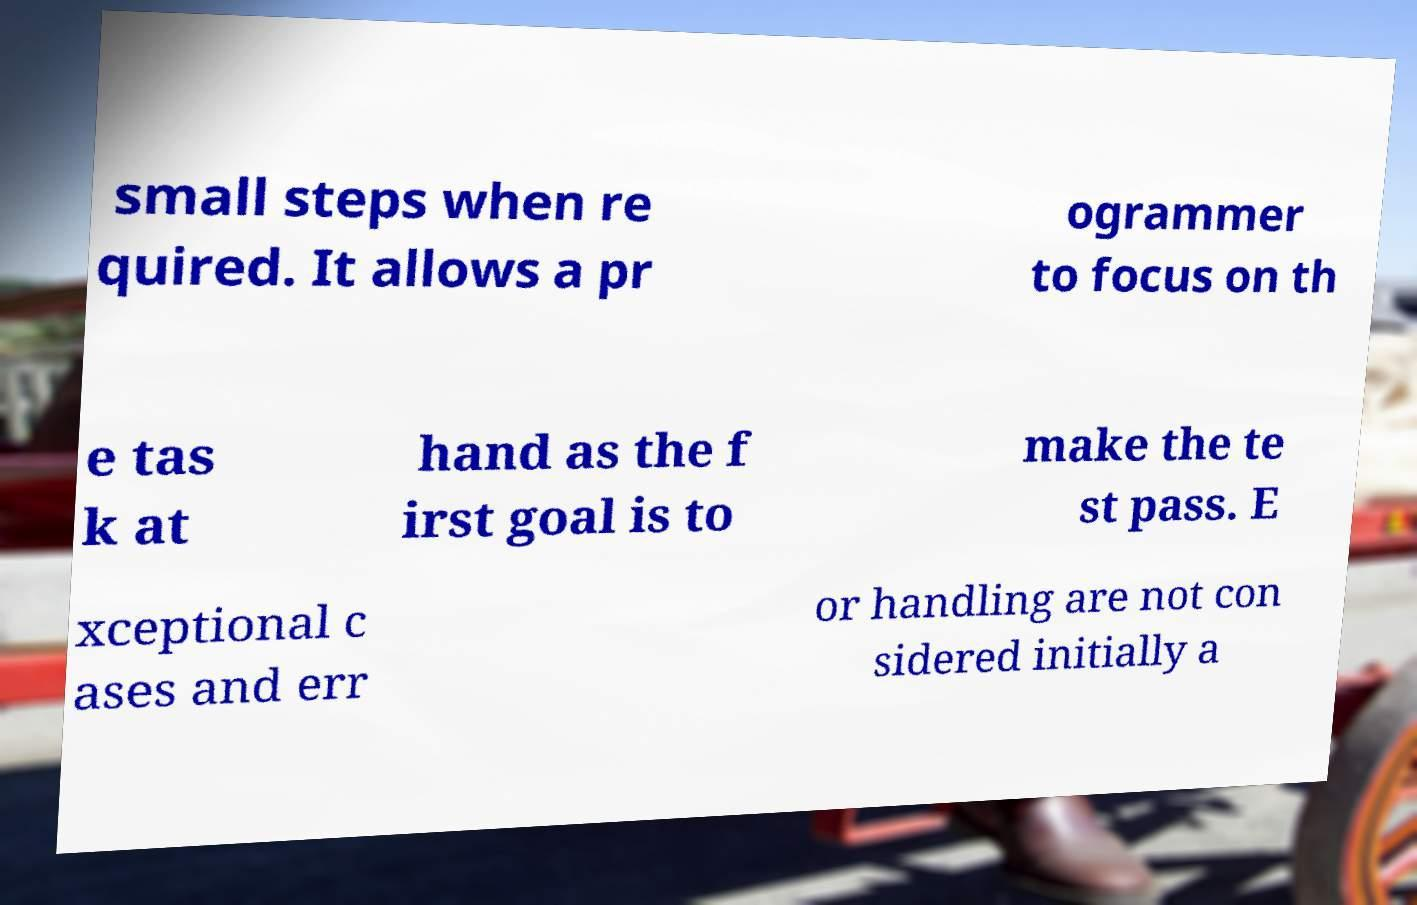Could you assist in decoding the text presented in this image and type it out clearly? small steps when re quired. It allows a pr ogrammer to focus on th e tas k at hand as the f irst goal is to make the te st pass. E xceptional c ases and err or handling are not con sidered initially a 